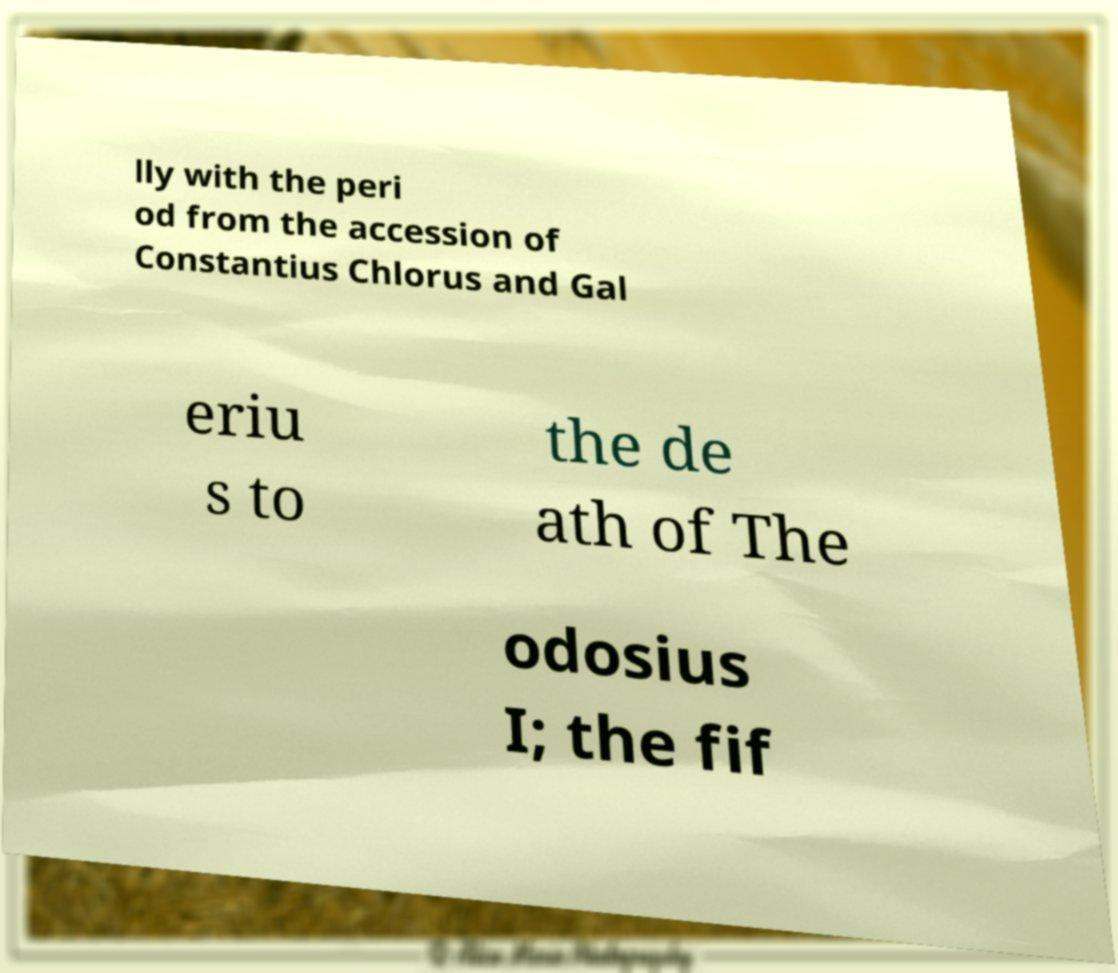Could you extract and type out the text from this image? lly with the peri od from the accession of Constantius Chlorus and Gal eriu s to the de ath of The odosius I; the fif 